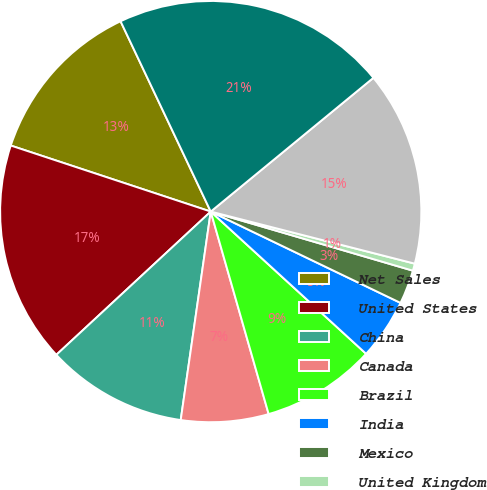Convert chart. <chart><loc_0><loc_0><loc_500><loc_500><pie_chart><fcel>Net Sales<fcel>United States<fcel>China<fcel>Canada<fcel>Brazil<fcel>India<fcel>Mexico<fcel>United Kingdom<fcel>Other foreign countries<fcel>Total net sales<nl><fcel>12.88%<fcel>16.98%<fcel>10.82%<fcel>6.71%<fcel>8.77%<fcel>4.66%<fcel>2.61%<fcel>0.55%<fcel>14.93%<fcel>21.09%<nl></chart> 